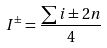Convert formula to latex. <formula><loc_0><loc_0><loc_500><loc_500>I ^ { \pm } = \frac { \sum i \pm 2 n } { 4 }</formula> 